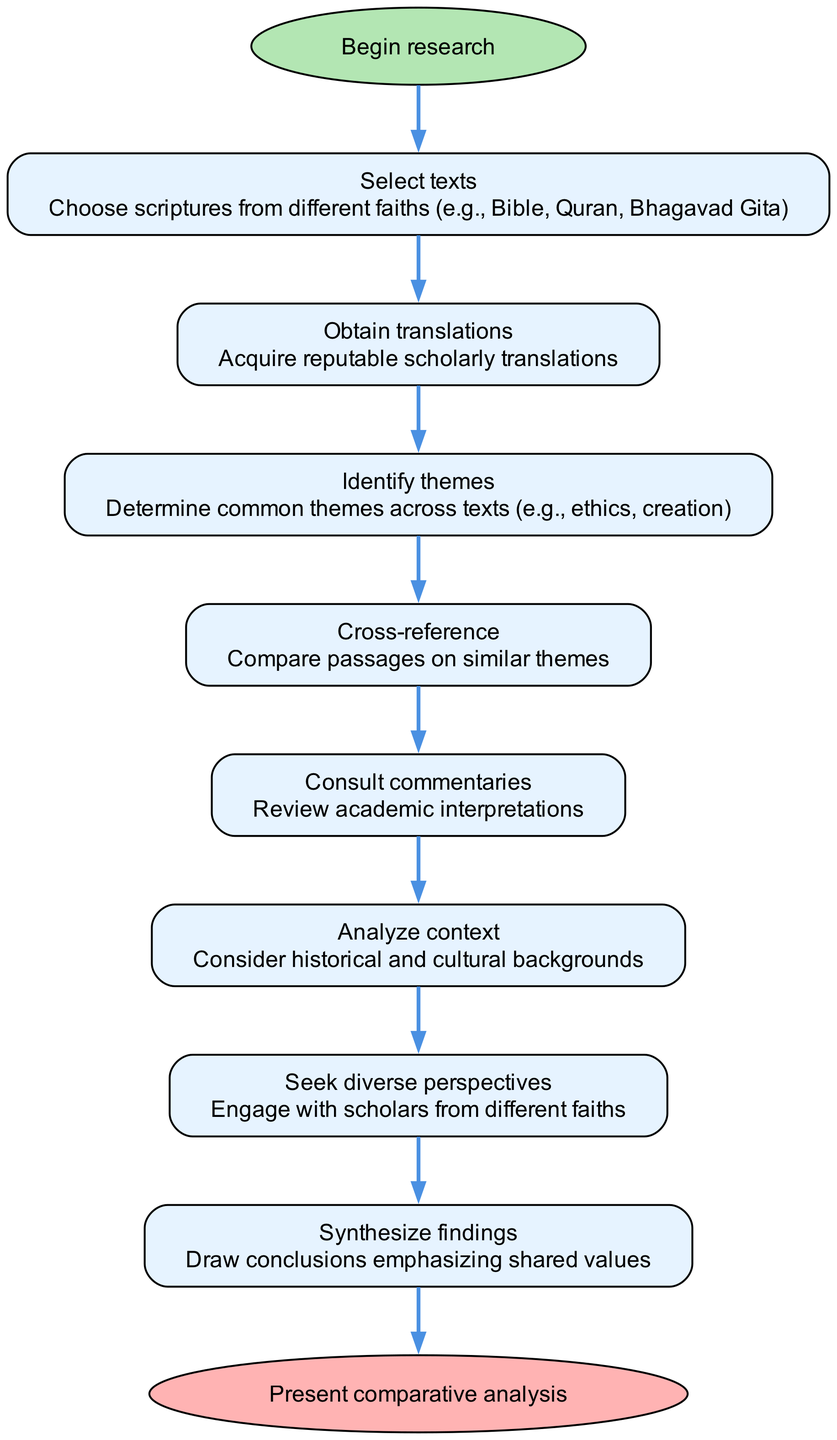What is the first step in the research process? The diagram indicates that the first step is "Select texts," which is listed directly after the "Begin research" node.
Answer: Select texts How many steps are there in the diagram? By counting the nodes representing individual steps, we can see that there are 8 steps, excluding the start and end nodes.
Answer: 8 What is the last step before presenting the comparative analysis? The final step before reaching the end node is "Synthesize findings," which is the step directly connected to the end node.
Answer: Synthesize findings What common action is emphasized in the second to last step of the process? The step "Synthesize findings" emphasizes the action of drawing conclusions, which is a culmination of the prior research efforts.
Answer: Draw conclusions Which step involves gathering scholarly insights? The step "Consult commentaries" specifically focuses on gathering insights from academic interpretations of the texts, resulting in scholarly engagement.
Answer: Consult commentaries What is the purpose of the "Seek diverse perspectives" step? This step emphasizes the importance of engaging with scholars from different faiths, aiming to broaden understanding and contextualize the texts.
Answer: Engaging with scholars Which two steps are connected directly? The connection from the step "Analyze context" to "Seek diverse perspectives" showcases the relationship and the flow of conducting research in an informed manner.
Answer: Analyze context and Seek diverse perspectives In what order do we compare passages on similar themes? The diagram suggests that after identifying themes in "Identify themes," we proceed to "Cross-reference" to compare relevant passages, indicating a sequential flow.
Answer: Identify themes, then Cross-reference 